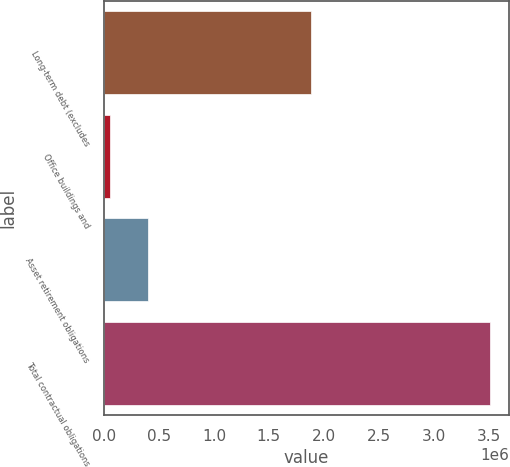<chart> <loc_0><loc_0><loc_500><loc_500><bar_chart><fcel>Long-term debt (excludes<fcel>Office buildings and<fcel>Asset retirement obligations<fcel>Total contractual obligations<nl><fcel>1.88e+06<fcel>52894<fcel>398878<fcel>3.51274e+06<nl></chart> 